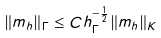Convert formula to latex. <formula><loc_0><loc_0><loc_500><loc_500>\| m _ { h } \| _ { \Gamma } \leq C h _ { \Gamma } ^ { - \frac { 1 } { 2 } } \| m _ { h } \| _ { K }</formula> 